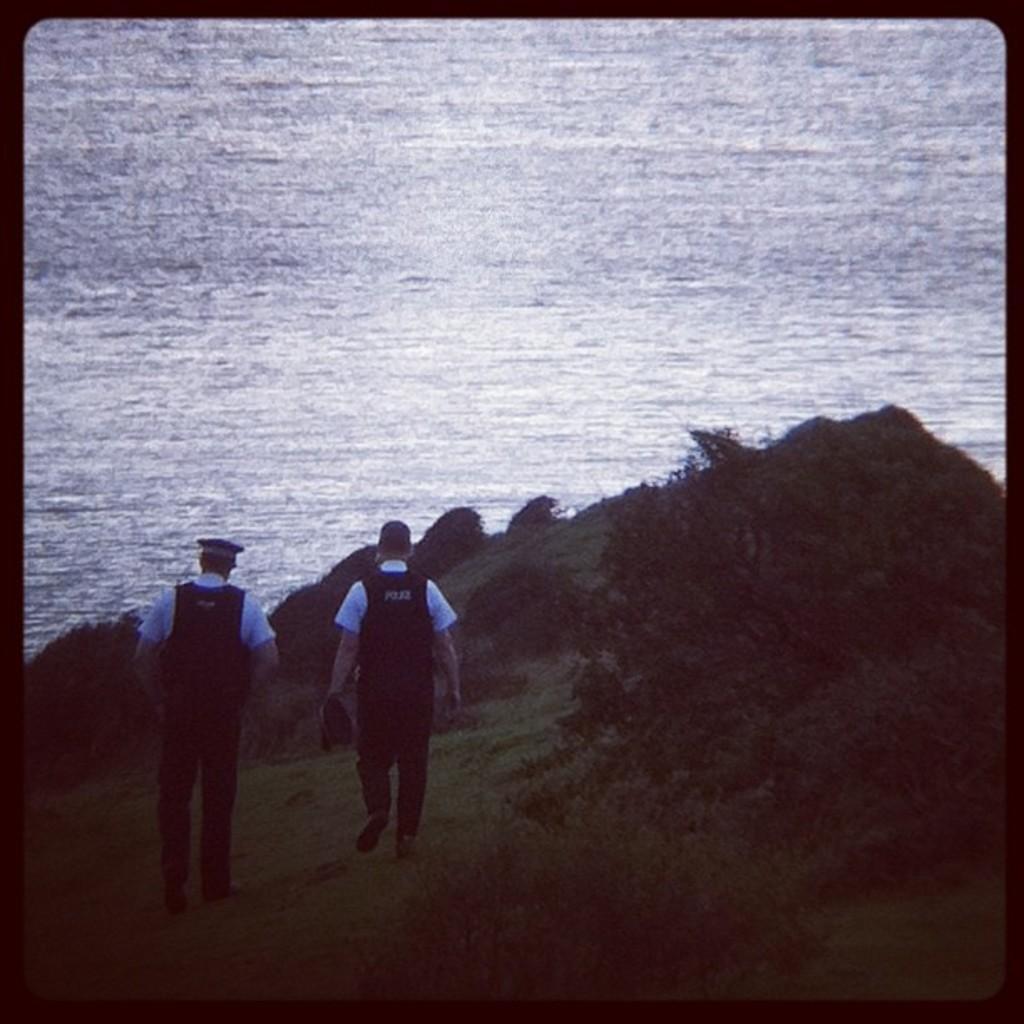Can you describe this image briefly? In the image there are two men walking. There is a man holding the cap in hand and there is another man with a cap on the head. There are trees on the ground. In front of them there is water. 